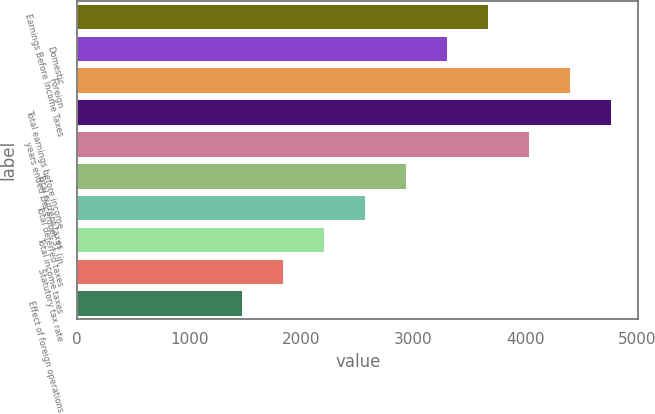Convert chart. <chart><loc_0><loc_0><loc_500><loc_500><bar_chart><fcel>Earnings Before Income Taxes<fcel>Domestic<fcel>Foreign<fcel>Total earnings before income<fcel>years ended December 31 (in<fcel>Total current taxes<fcel>Total deferred taxes<fcel>Total income taxes<fcel>Statutory tax rate<fcel>Effect of foreign operations<nl><fcel>3668<fcel>3301.23<fcel>4401.54<fcel>4768.31<fcel>4034.77<fcel>2934.46<fcel>2567.69<fcel>2200.92<fcel>1834.15<fcel>1467.38<nl></chart> 